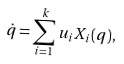<formula> <loc_0><loc_0><loc_500><loc_500>\dot { q } = \sum _ { i = 1 } ^ { k } u _ { i } X _ { i } ( q ) ,</formula> 